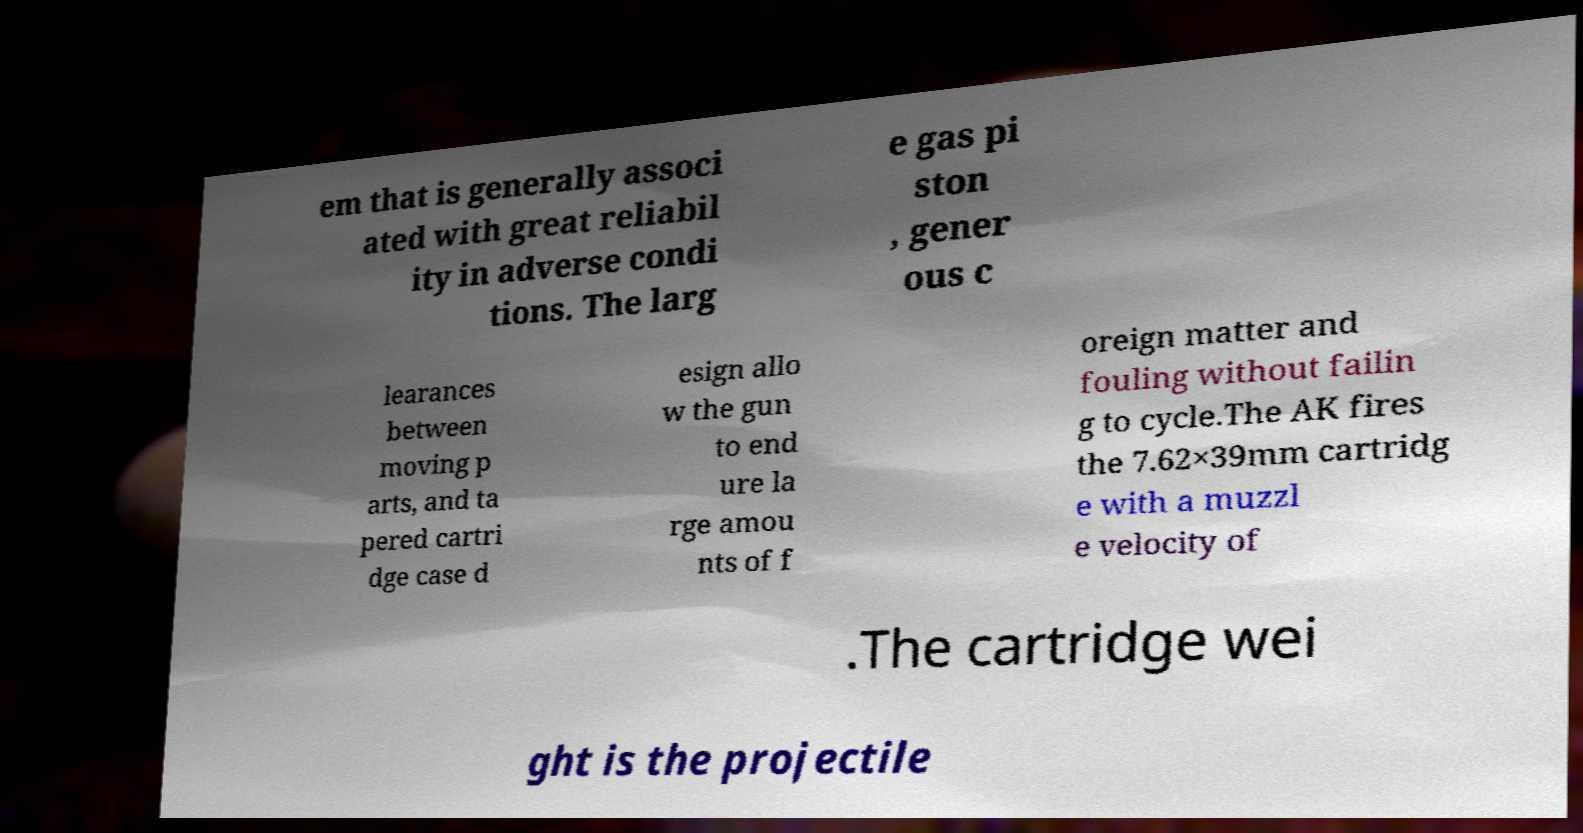Could you assist in decoding the text presented in this image and type it out clearly? em that is generally associ ated with great reliabil ity in adverse condi tions. The larg e gas pi ston , gener ous c learances between moving p arts, and ta pered cartri dge case d esign allo w the gun to end ure la rge amou nts of f oreign matter and fouling without failin g to cycle.The AK fires the 7.62×39mm cartridg e with a muzzl e velocity of .The cartridge wei ght is the projectile 